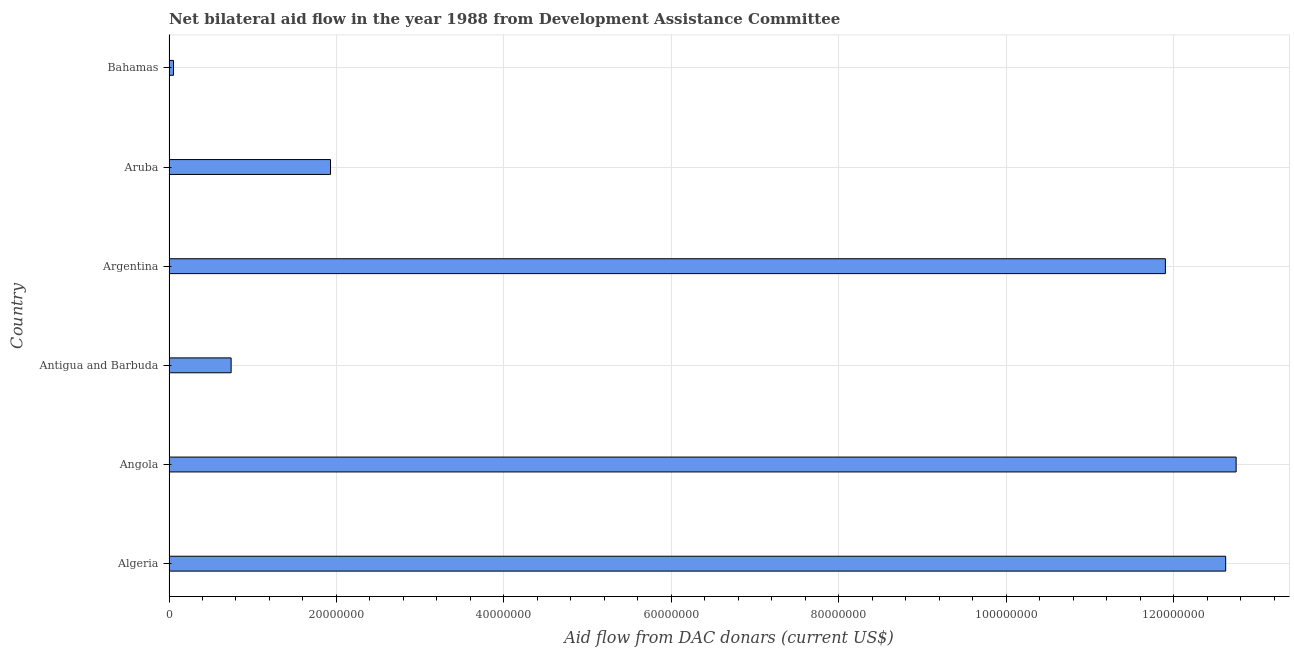What is the title of the graph?
Give a very brief answer. Net bilateral aid flow in the year 1988 from Development Assistance Committee. What is the label or title of the X-axis?
Provide a short and direct response. Aid flow from DAC donars (current US$). What is the net bilateral aid flows from dac donors in Aruba?
Keep it short and to the point. 1.93e+07. Across all countries, what is the maximum net bilateral aid flows from dac donors?
Provide a short and direct response. 1.27e+08. Across all countries, what is the minimum net bilateral aid flows from dac donors?
Give a very brief answer. 5.40e+05. In which country was the net bilateral aid flows from dac donors maximum?
Give a very brief answer. Angola. In which country was the net bilateral aid flows from dac donors minimum?
Offer a very short reply. Bahamas. What is the sum of the net bilateral aid flows from dac donors?
Ensure brevity in your answer.  4.00e+08. What is the difference between the net bilateral aid flows from dac donors in Algeria and Aruba?
Provide a succinct answer. 1.07e+08. What is the average net bilateral aid flows from dac donors per country?
Ensure brevity in your answer.  6.66e+07. What is the median net bilateral aid flows from dac donors?
Offer a very short reply. 6.91e+07. What is the ratio of the net bilateral aid flows from dac donors in Algeria to that in Aruba?
Provide a succinct answer. 6.54. Is the net bilateral aid flows from dac donors in Algeria less than that in Bahamas?
Keep it short and to the point. No. What is the difference between the highest and the second highest net bilateral aid flows from dac donors?
Your answer should be compact. 1.25e+06. What is the difference between the highest and the lowest net bilateral aid flows from dac donors?
Your answer should be very brief. 1.27e+08. How many bars are there?
Your response must be concise. 6. How many countries are there in the graph?
Provide a succinct answer. 6. What is the Aid flow from DAC donars (current US$) of Algeria?
Give a very brief answer. 1.26e+08. What is the Aid flow from DAC donars (current US$) in Angola?
Give a very brief answer. 1.27e+08. What is the Aid flow from DAC donars (current US$) in Antigua and Barbuda?
Provide a succinct answer. 7.42e+06. What is the Aid flow from DAC donars (current US$) in Argentina?
Offer a terse response. 1.19e+08. What is the Aid flow from DAC donars (current US$) in Aruba?
Your answer should be compact. 1.93e+07. What is the Aid flow from DAC donars (current US$) in Bahamas?
Provide a succinct answer. 5.40e+05. What is the difference between the Aid flow from DAC donars (current US$) in Algeria and Angola?
Your answer should be compact. -1.25e+06. What is the difference between the Aid flow from DAC donars (current US$) in Algeria and Antigua and Barbuda?
Offer a very short reply. 1.19e+08. What is the difference between the Aid flow from DAC donars (current US$) in Algeria and Argentina?
Provide a succinct answer. 7.20e+06. What is the difference between the Aid flow from DAC donars (current US$) in Algeria and Aruba?
Offer a very short reply. 1.07e+08. What is the difference between the Aid flow from DAC donars (current US$) in Algeria and Bahamas?
Provide a short and direct response. 1.26e+08. What is the difference between the Aid flow from DAC donars (current US$) in Angola and Antigua and Barbuda?
Give a very brief answer. 1.20e+08. What is the difference between the Aid flow from DAC donars (current US$) in Angola and Argentina?
Keep it short and to the point. 8.45e+06. What is the difference between the Aid flow from DAC donars (current US$) in Angola and Aruba?
Your answer should be very brief. 1.08e+08. What is the difference between the Aid flow from DAC donars (current US$) in Angola and Bahamas?
Offer a terse response. 1.27e+08. What is the difference between the Aid flow from DAC donars (current US$) in Antigua and Barbuda and Argentina?
Provide a short and direct response. -1.12e+08. What is the difference between the Aid flow from DAC donars (current US$) in Antigua and Barbuda and Aruba?
Your answer should be compact. -1.19e+07. What is the difference between the Aid flow from DAC donars (current US$) in Antigua and Barbuda and Bahamas?
Make the answer very short. 6.88e+06. What is the difference between the Aid flow from DAC donars (current US$) in Argentina and Aruba?
Offer a very short reply. 9.97e+07. What is the difference between the Aid flow from DAC donars (current US$) in Argentina and Bahamas?
Provide a short and direct response. 1.18e+08. What is the difference between the Aid flow from DAC donars (current US$) in Aruba and Bahamas?
Give a very brief answer. 1.88e+07. What is the ratio of the Aid flow from DAC donars (current US$) in Algeria to that in Antigua and Barbuda?
Give a very brief answer. 17.01. What is the ratio of the Aid flow from DAC donars (current US$) in Algeria to that in Argentina?
Your answer should be compact. 1.06. What is the ratio of the Aid flow from DAC donars (current US$) in Algeria to that in Aruba?
Provide a short and direct response. 6.54. What is the ratio of the Aid flow from DAC donars (current US$) in Algeria to that in Bahamas?
Provide a short and direct response. 233.7. What is the ratio of the Aid flow from DAC donars (current US$) in Angola to that in Antigua and Barbuda?
Your response must be concise. 17.18. What is the ratio of the Aid flow from DAC donars (current US$) in Angola to that in Argentina?
Your answer should be compact. 1.07. What is the ratio of the Aid flow from DAC donars (current US$) in Angola to that in Aruba?
Ensure brevity in your answer.  6.61. What is the ratio of the Aid flow from DAC donars (current US$) in Angola to that in Bahamas?
Give a very brief answer. 236.02. What is the ratio of the Aid flow from DAC donars (current US$) in Antigua and Barbuda to that in Argentina?
Your response must be concise. 0.06. What is the ratio of the Aid flow from DAC donars (current US$) in Antigua and Barbuda to that in Aruba?
Keep it short and to the point. 0.39. What is the ratio of the Aid flow from DAC donars (current US$) in Antigua and Barbuda to that in Bahamas?
Your response must be concise. 13.74. What is the ratio of the Aid flow from DAC donars (current US$) in Argentina to that in Aruba?
Keep it short and to the point. 6.17. What is the ratio of the Aid flow from DAC donars (current US$) in Argentina to that in Bahamas?
Give a very brief answer. 220.37. What is the ratio of the Aid flow from DAC donars (current US$) in Aruba to that in Bahamas?
Your answer should be compact. 35.72. 